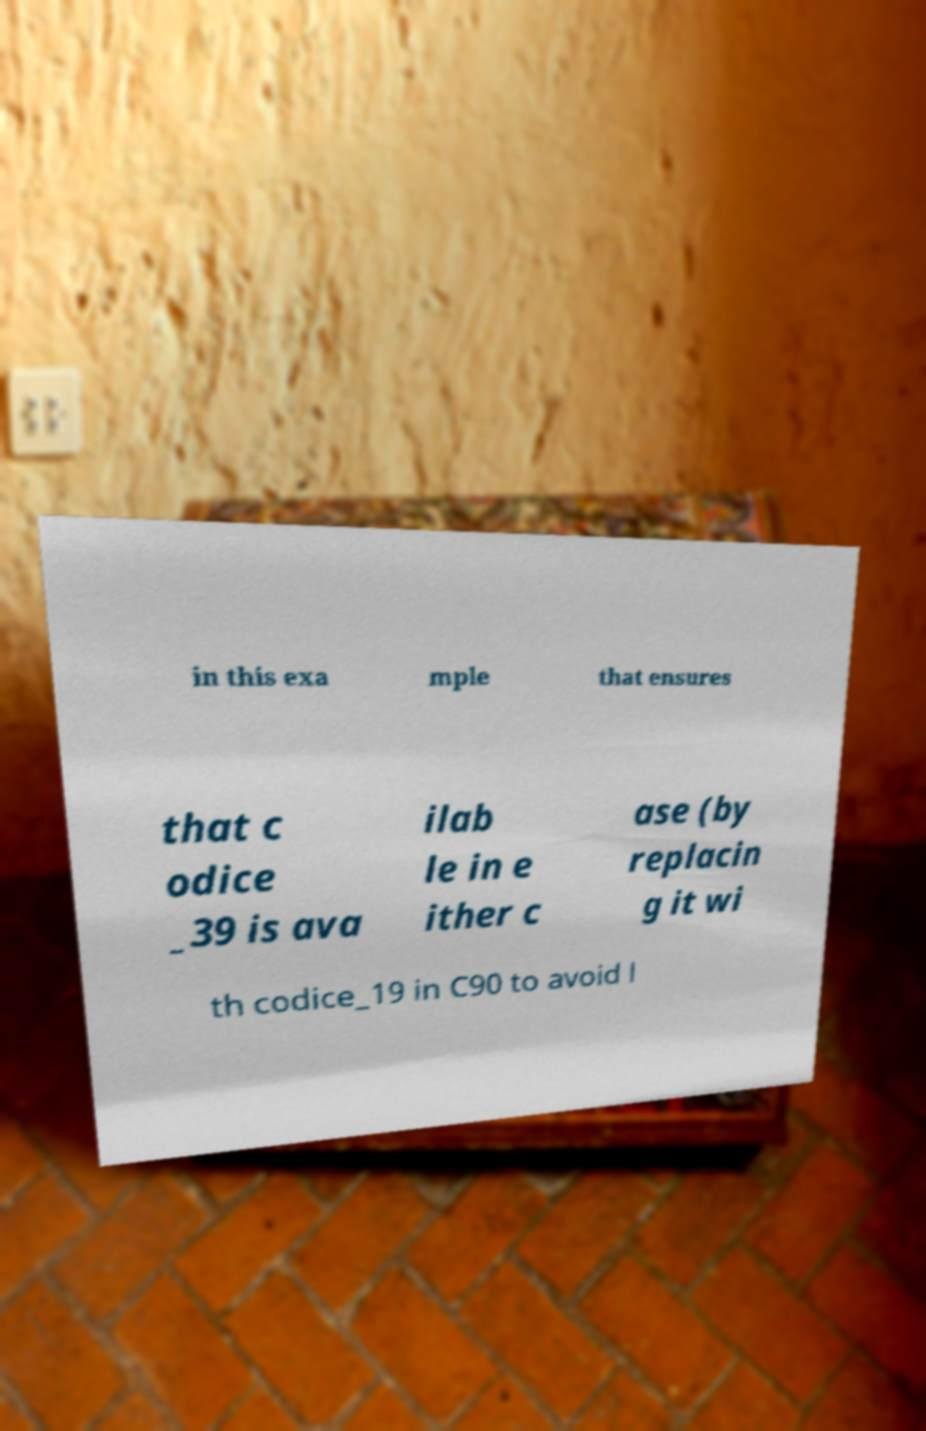Could you extract and type out the text from this image? in this exa mple that ensures that c odice _39 is ava ilab le in e ither c ase (by replacin g it wi th codice_19 in C90 to avoid l 